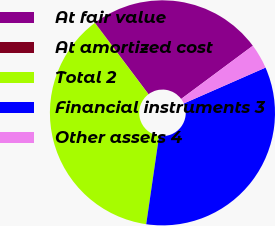Convert chart to OTSL. <chart><loc_0><loc_0><loc_500><loc_500><pie_chart><fcel>At fair value<fcel>At amortized cost<fcel>Total 2<fcel>Financial instruments 3<fcel>Other assets 4<nl><fcel>25.06%<fcel>0.05%<fcel>37.42%<fcel>33.89%<fcel>3.58%<nl></chart> 